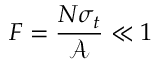Convert formula to latex. <formula><loc_0><loc_0><loc_500><loc_500>F = \frac { N \sigma _ { t } } { \mathcal { A } } \ll 1</formula> 